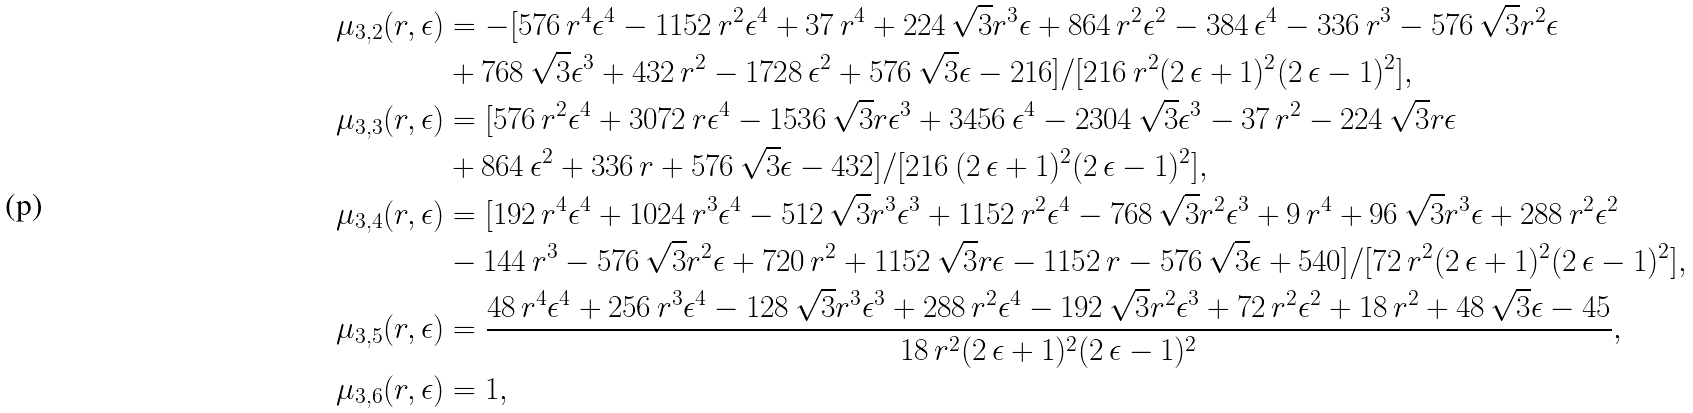Convert formula to latex. <formula><loc_0><loc_0><loc_500><loc_500>\mu _ { 3 , 2 } ( r , \epsilon ) & = - [ 5 7 6 \, r ^ { 4 } \epsilon ^ { 4 } - 1 1 5 2 \, r ^ { 2 } \epsilon ^ { 4 } + 3 7 \, r ^ { 4 } + 2 2 4 \, \sqrt { 3 } r ^ { 3 } \epsilon + 8 6 4 \, r ^ { 2 } \epsilon ^ { 2 } - 3 8 4 \, \epsilon ^ { 4 } - 3 3 6 \, r ^ { 3 } - 5 7 6 \, \sqrt { 3 } r ^ { 2 } \epsilon \\ & + 7 6 8 \, \sqrt { 3 } \epsilon ^ { 3 } + 4 3 2 \, r ^ { 2 } - 1 7 2 8 \, \epsilon ^ { 2 } + 5 7 6 \, \sqrt { 3 } \epsilon - 2 1 6 ] / [ 2 1 6 \, r ^ { 2 } ( 2 \, \epsilon + 1 ) ^ { 2 } ( 2 \, \epsilon - 1 ) ^ { 2 } ] , \\ \mu _ { 3 , 3 } ( r , \epsilon ) & = [ 5 7 6 \, r ^ { 2 } \epsilon ^ { 4 } + 3 0 7 2 \, r \epsilon ^ { 4 } - 1 5 3 6 \, \sqrt { 3 } r \epsilon ^ { 3 } + 3 4 5 6 \, \epsilon ^ { 4 } - 2 3 0 4 \, \sqrt { 3 } \epsilon ^ { 3 } - 3 7 \, r ^ { 2 } - 2 2 4 \, \sqrt { 3 } r \epsilon \\ & + 8 6 4 \, \epsilon ^ { 2 } + 3 3 6 \, r + 5 7 6 \, \sqrt { 3 } \epsilon - 4 3 2 ] / [ 2 1 6 \, ( 2 \, \epsilon + 1 ) ^ { 2 } ( 2 \, \epsilon - 1 ) ^ { 2 } ] , \\ \mu _ { 3 , 4 } ( r , \epsilon ) & = [ 1 9 2 \, r ^ { 4 } \epsilon ^ { 4 } + 1 0 2 4 \, r ^ { 3 } \epsilon ^ { 4 } - 5 1 2 \, \sqrt { 3 } r ^ { 3 } \epsilon ^ { 3 } + 1 1 5 2 \, r ^ { 2 } \epsilon ^ { 4 } - 7 6 8 \, \sqrt { 3 } r ^ { 2 } \epsilon ^ { 3 } + 9 \, r ^ { 4 } + 9 6 \, \sqrt { 3 } r ^ { 3 } \epsilon + 2 8 8 \, r ^ { 2 } \epsilon ^ { 2 } \\ & - 1 4 4 \, r ^ { 3 } - 5 7 6 \, \sqrt { 3 } r ^ { 2 } \epsilon + 7 2 0 \, r ^ { 2 } + 1 1 5 2 \, \sqrt { 3 } r \epsilon - 1 1 5 2 \, r - 5 7 6 \, \sqrt { 3 } \epsilon + 5 4 0 ] / [ 7 2 \, r ^ { 2 } ( 2 \, \epsilon + 1 ) ^ { 2 } ( 2 \, \epsilon - 1 ) ^ { 2 } ] , \\ \mu _ { 3 , 5 } ( r , \epsilon ) & = \frac { 4 8 \, r ^ { 4 } \epsilon ^ { 4 } + 2 5 6 \, r ^ { 3 } \epsilon ^ { 4 } - 1 2 8 \, \sqrt { 3 } r ^ { 3 } \epsilon ^ { 3 } + 2 8 8 \, r ^ { 2 } \epsilon ^ { 4 } - 1 9 2 \, \sqrt { 3 } r ^ { 2 } \epsilon ^ { 3 } + 7 2 \, r ^ { 2 } \epsilon ^ { 2 } + 1 8 \, r ^ { 2 } + 4 8 \, \sqrt { 3 } \epsilon - 4 5 } { 1 8 \, r ^ { 2 } ( 2 \, \epsilon + 1 ) ^ { 2 } ( 2 \, \epsilon - 1 ) ^ { 2 } } , \\ \mu _ { 3 , 6 } ( r , \epsilon ) & = 1 ,</formula> 